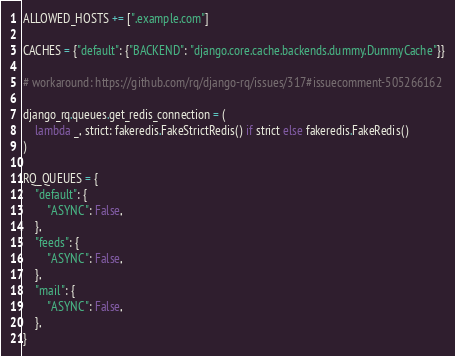Convert code to text. <code><loc_0><loc_0><loc_500><loc_500><_Python_>
ALLOWED_HOSTS += [".example.com"]

CACHES = {"default": {"BACKEND": "django.core.cache.backends.dummy.DummyCache"}}

# workaround: https://github.com/rq/django-rq/issues/317#issuecomment-505266162

django_rq.queues.get_redis_connection = (
    lambda _, strict: fakeredis.FakeStrictRedis() if strict else fakeredis.FakeRedis()
)

RQ_QUEUES = {
    "default": {
        "ASYNC": False,
    },
    "feeds": {
        "ASYNC": False,
    },
    "mail": {
        "ASYNC": False,
    },
}
</code> 